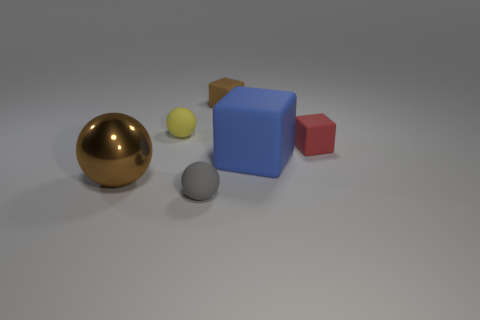What number of objects are matte cylinders or large brown balls?
Ensure brevity in your answer.  1. There is a brown thing that is the same shape as the yellow object; what is its size?
Ensure brevity in your answer.  Large. What size is the yellow thing?
Your answer should be very brief. Small. Are there more large blue rubber objects that are on the left side of the large brown thing than yellow objects?
Your answer should be compact. No. Is there any other thing that is the same material as the small brown object?
Make the answer very short. Yes. There is a tiny matte thing on the left side of the tiny gray object; does it have the same color as the small object in front of the big metal object?
Offer a terse response. No. What is the thing that is left of the yellow rubber ball that is in front of the brown thing that is on the right side of the yellow object made of?
Keep it short and to the point. Metal. Are there more small matte balls than gray balls?
Make the answer very short. Yes. Are there any other things that have the same color as the big cube?
Provide a short and direct response. No. What size is the yellow thing that is made of the same material as the tiny gray object?
Give a very brief answer. Small. 